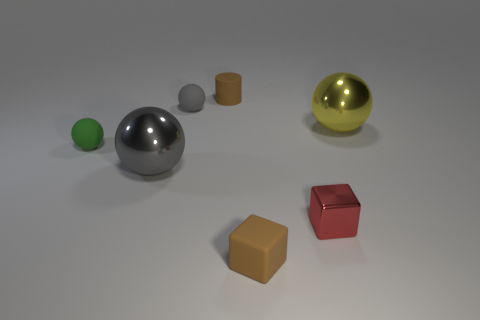Do the gray shiny object and the tiny gray thing have the same shape?
Offer a terse response. Yes. What number of tiny objects are behind the matte cube?
Your response must be concise. 4. The large metallic thing that is to the right of the small thing that is in front of the small red block is what shape?
Ensure brevity in your answer.  Sphere. There is another large thing that is made of the same material as the big yellow object; what is its shape?
Offer a very short reply. Sphere. There is a sphere in front of the green object; is its size the same as the sphere on the right side of the brown matte cylinder?
Keep it short and to the point. Yes. There is a object that is to the right of the tiny red metallic thing; what shape is it?
Provide a short and direct response. Sphere. The rubber block has what color?
Give a very brief answer. Brown. Does the red thing have the same size as the brown cylinder behind the large gray object?
Make the answer very short. Yes. What number of metallic things are green things or tiny brown cubes?
Your answer should be very brief. 0. There is a rubber cube; is its color the same as the small thing that is behind the gray rubber object?
Give a very brief answer. Yes. 